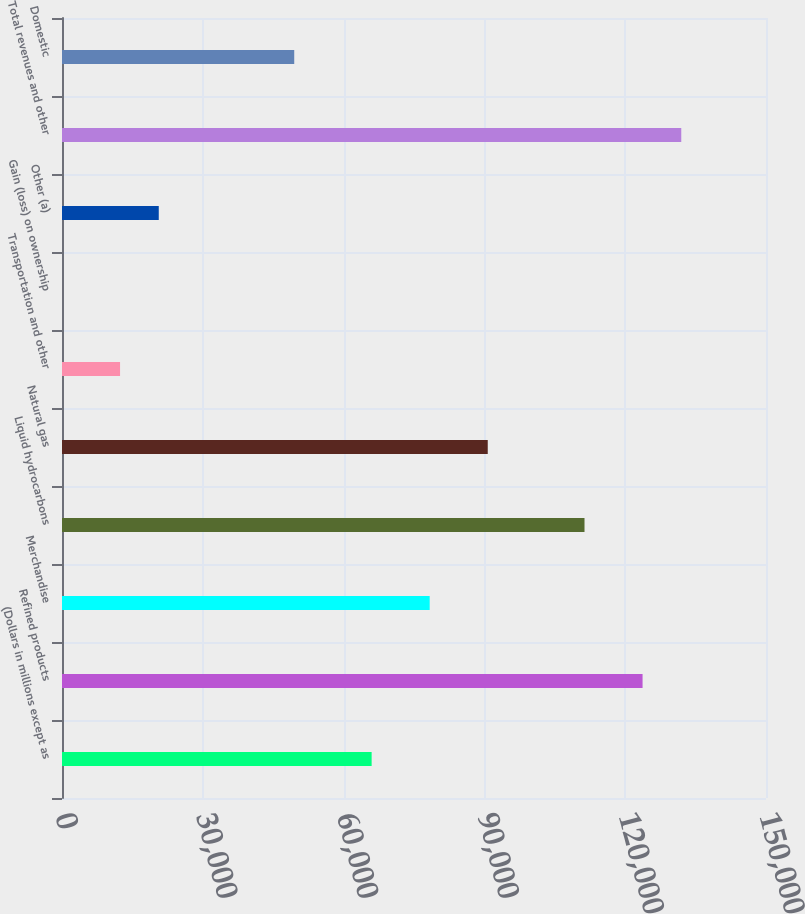Convert chart to OTSL. <chart><loc_0><loc_0><loc_500><loc_500><bar_chart><fcel>(Dollars in millions except as<fcel>Refined products<fcel>Merchandise<fcel>Liquid hydrocarbons<fcel>Natural gas<fcel>Transportation and other<fcel>Gain (loss) on ownership<fcel>Other (a)<fcel>Total revenues and other<fcel>Domestic<nl><fcel>65973.8<fcel>123700<fcel>78343.7<fcel>111330<fcel>90713.6<fcel>12370.9<fcel>1<fcel>20617.5<fcel>131947<fcel>49480.6<nl></chart> 